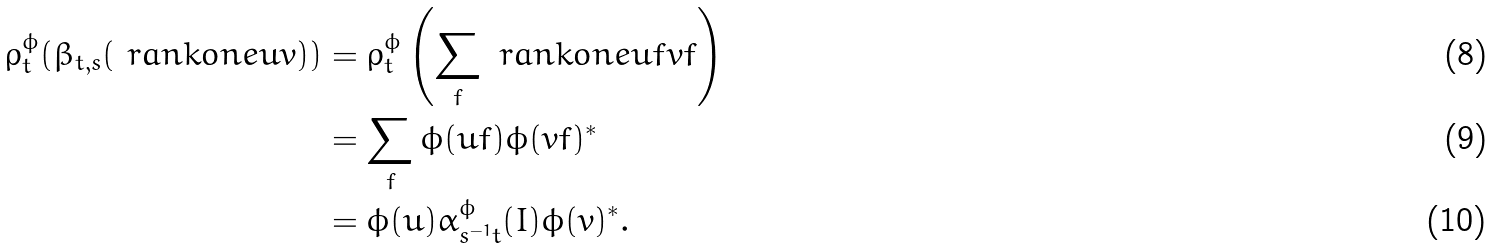<formula> <loc_0><loc_0><loc_500><loc_500>\rho ^ { \phi } _ { t } ( \beta _ { t , s } ( \ r a n k o n e u v ) ) & = \rho ^ { \phi } _ { t } \left ( \sum _ { f } \ r a n k o n e { u f } { v f } \right ) \\ & = \sum _ { f } \phi ( u f ) \phi ( v f ) ^ { * } \\ & = \phi ( u ) \alpha ^ { \phi } _ { s ^ { - 1 } t } ( I ) \phi ( v ) ^ { * } .</formula> 